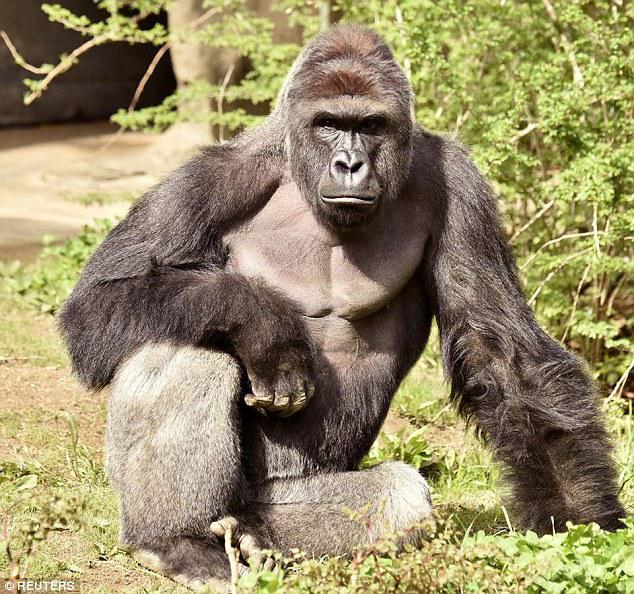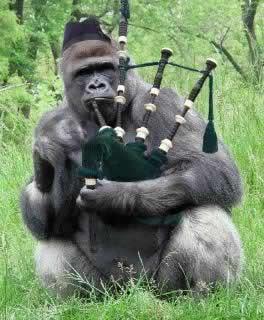The first image is the image on the left, the second image is the image on the right. Given the left and right images, does the statement "the left and right image contains the same number of gorillas with human clothing." hold true? Answer yes or no. No. The first image is the image on the left, the second image is the image on the right. Given the left and right images, does the statement "A gorilla is shown with an item of clothing in each image." hold true? Answer yes or no. No. 